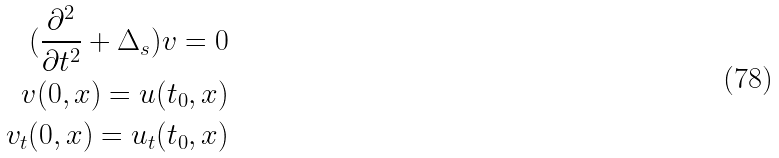Convert formula to latex. <formula><loc_0><loc_0><loc_500><loc_500>( \frac { \partial ^ { 2 } } { \partial t ^ { 2 } } + \Delta _ { s } ) v = 0 \\ v ( 0 , x ) = u ( t _ { 0 } , x ) \\ v _ { t } ( 0 , x ) = u _ { t } ( t _ { 0 } , x )</formula> 